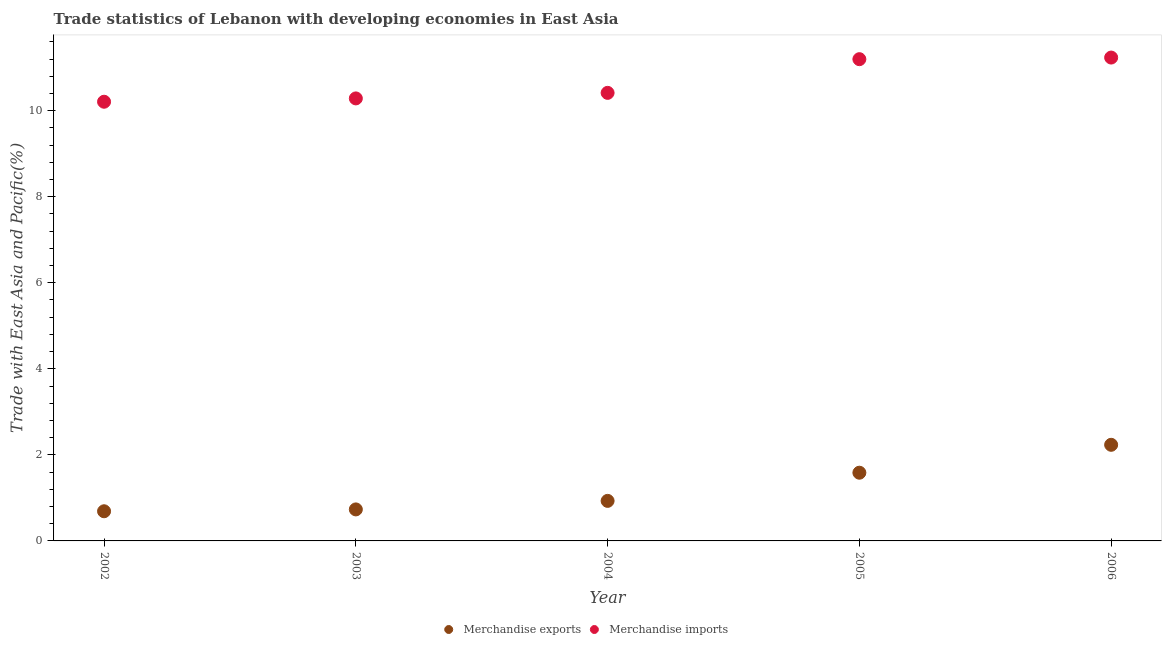How many different coloured dotlines are there?
Offer a terse response. 2. What is the merchandise exports in 2006?
Ensure brevity in your answer.  2.23. Across all years, what is the maximum merchandise imports?
Keep it short and to the point. 11.23. Across all years, what is the minimum merchandise exports?
Ensure brevity in your answer.  0.69. In which year was the merchandise exports minimum?
Ensure brevity in your answer.  2002. What is the total merchandise exports in the graph?
Your answer should be compact. 6.17. What is the difference between the merchandise imports in 2004 and that in 2006?
Make the answer very short. -0.82. What is the difference between the merchandise imports in 2006 and the merchandise exports in 2005?
Provide a short and direct response. 9.65. What is the average merchandise imports per year?
Your answer should be very brief. 10.67. In the year 2003, what is the difference between the merchandise exports and merchandise imports?
Offer a very short reply. -9.55. In how many years, is the merchandise imports greater than 0.4 %?
Your answer should be very brief. 5. What is the ratio of the merchandise exports in 2003 to that in 2006?
Provide a short and direct response. 0.33. What is the difference between the highest and the second highest merchandise exports?
Ensure brevity in your answer.  0.65. What is the difference between the highest and the lowest merchandise exports?
Your response must be concise. 1.54. In how many years, is the merchandise imports greater than the average merchandise imports taken over all years?
Provide a succinct answer. 2. Does the merchandise imports monotonically increase over the years?
Your answer should be very brief. Yes. Is the merchandise exports strictly less than the merchandise imports over the years?
Your answer should be compact. Yes. How many dotlines are there?
Offer a very short reply. 2. What is the difference between two consecutive major ticks on the Y-axis?
Provide a short and direct response. 2. Does the graph contain any zero values?
Make the answer very short. No. Does the graph contain grids?
Offer a very short reply. No. Where does the legend appear in the graph?
Make the answer very short. Bottom center. How many legend labels are there?
Offer a very short reply. 2. What is the title of the graph?
Ensure brevity in your answer.  Trade statistics of Lebanon with developing economies in East Asia. Does "Manufacturing industries and construction" appear as one of the legend labels in the graph?
Provide a short and direct response. No. What is the label or title of the X-axis?
Ensure brevity in your answer.  Year. What is the label or title of the Y-axis?
Keep it short and to the point. Trade with East Asia and Pacific(%). What is the Trade with East Asia and Pacific(%) of Merchandise exports in 2002?
Your answer should be very brief. 0.69. What is the Trade with East Asia and Pacific(%) of Merchandise imports in 2002?
Give a very brief answer. 10.21. What is the Trade with East Asia and Pacific(%) of Merchandise exports in 2003?
Your response must be concise. 0.73. What is the Trade with East Asia and Pacific(%) of Merchandise imports in 2003?
Your answer should be very brief. 10.29. What is the Trade with East Asia and Pacific(%) in Merchandise exports in 2004?
Your answer should be very brief. 0.93. What is the Trade with East Asia and Pacific(%) in Merchandise imports in 2004?
Make the answer very short. 10.41. What is the Trade with East Asia and Pacific(%) in Merchandise exports in 2005?
Your response must be concise. 1.59. What is the Trade with East Asia and Pacific(%) of Merchandise imports in 2005?
Offer a terse response. 11.2. What is the Trade with East Asia and Pacific(%) of Merchandise exports in 2006?
Make the answer very short. 2.23. What is the Trade with East Asia and Pacific(%) in Merchandise imports in 2006?
Offer a very short reply. 11.23. Across all years, what is the maximum Trade with East Asia and Pacific(%) of Merchandise exports?
Ensure brevity in your answer.  2.23. Across all years, what is the maximum Trade with East Asia and Pacific(%) of Merchandise imports?
Your response must be concise. 11.23. Across all years, what is the minimum Trade with East Asia and Pacific(%) in Merchandise exports?
Your response must be concise. 0.69. Across all years, what is the minimum Trade with East Asia and Pacific(%) of Merchandise imports?
Ensure brevity in your answer.  10.21. What is the total Trade with East Asia and Pacific(%) of Merchandise exports in the graph?
Keep it short and to the point. 6.17. What is the total Trade with East Asia and Pacific(%) in Merchandise imports in the graph?
Make the answer very short. 53.34. What is the difference between the Trade with East Asia and Pacific(%) of Merchandise exports in 2002 and that in 2003?
Your response must be concise. -0.04. What is the difference between the Trade with East Asia and Pacific(%) in Merchandise imports in 2002 and that in 2003?
Provide a succinct answer. -0.08. What is the difference between the Trade with East Asia and Pacific(%) of Merchandise exports in 2002 and that in 2004?
Provide a succinct answer. -0.24. What is the difference between the Trade with East Asia and Pacific(%) of Merchandise imports in 2002 and that in 2004?
Offer a terse response. -0.21. What is the difference between the Trade with East Asia and Pacific(%) in Merchandise exports in 2002 and that in 2005?
Give a very brief answer. -0.9. What is the difference between the Trade with East Asia and Pacific(%) in Merchandise imports in 2002 and that in 2005?
Your answer should be compact. -0.99. What is the difference between the Trade with East Asia and Pacific(%) in Merchandise exports in 2002 and that in 2006?
Offer a very short reply. -1.54. What is the difference between the Trade with East Asia and Pacific(%) in Merchandise imports in 2002 and that in 2006?
Ensure brevity in your answer.  -1.03. What is the difference between the Trade with East Asia and Pacific(%) in Merchandise exports in 2003 and that in 2004?
Provide a succinct answer. -0.2. What is the difference between the Trade with East Asia and Pacific(%) in Merchandise imports in 2003 and that in 2004?
Your answer should be compact. -0.13. What is the difference between the Trade with East Asia and Pacific(%) of Merchandise exports in 2003 and that in 2005?
Provide a short and direct response. -0.85. What is the difference between the Trade with East Asia and Pacific(%) in Merchandise imports in 2003 and that in 2005?
Make the answer very short. -0.91. What is the difference between the Trade with East Asia and Pacific(%) of Merchandise exports in 2003 and that in 2006?
Offer a very short reply. -1.5. What is the difference between the Trade with East Asia and Pacific(%) in Merchandise imports in 2003 and that in 2006?
Your response must be concise. -0.95. What is the difference between the Trade with East Asia and Pacific(%) in Merchandise exports in 2004 and that in 2005?
Provide a succinct answer. -0.65. What is the difference between the Trade with East Asia and Pacific(%) of Merchandise imports in 2004 and that in 2005?
Offer a terse response. -0.78. What is the difference between the Trade with East Asia and Pacific(%) of Merchandise exports in 2004 and that in 2006?
Your answer should be very brief. -1.3. What is the difference between the Trade with East Asia and Pacific(%) of Merchandise imports in 2004 and that in 2006?
Provide a short and direct response. -0.82. What is the difference between the Trade with East Asia and Pacific(%) of Merchandise exports in 2005 and that in 2006?
Provide a short and direct response. -0.65. What is the difference between the Trade with East Asia and Pacific(%) in Merchandise imports in 2005 and that in 2006?
Provide a short and direct response. -0.04. What is the difference between the Trade with East Asia and Pacific(%) of Merchandise exports in 2002 and the Trade with East Asia and Pacific(%) of Merchandise imports in 2003?
Give a very brief answer. -9.6. What is the difference between the Trade with East Asia and Pacific(%) in Merchandise exports in 2002 and the Trade with East Asia and Pacific(%) in Merchandise imports in 2004?
Offer a terse response. -9.72. What is the difference between the Trade with East Asia and Pacific(%) in Merchandise exports in 2002 and the Trade with East Asia and Pacific(%) in Merchandise imports in 2005?
Make the answer very short. -10.51. What is the difference between the Trade with East Asia and Pacific(%) in Merchandise exports in 2002 and the Trade with East Asia and Pacific(%) in Merchandise imports in 2006?
Provide a succinct answer. -10.55. What is the difference between the Trade with East Asia and Pacific(%) of Merchandise exports in 2003 and the Trade with East Asia and Pacific(%) of Merchandise imports in 2004?
Keep it short and to the point. -9.68. What is the difference between the Trade with East Asia and Pacific(%) of Merchandise exports in 2003 and the Trade with East Asia and Pacific(%) of Merchandise imports in 2005?
Make the answer very short. -10.46. What is the difference between the Trade with East Asia and Pacific(%) of Merchandise exports in 2003 and the Trade with East Asia and Pacific(%) of Merchandise imports in 2006?
Provide a short and direct response. -10.5. What is the difference between the Trade with East Asia and Pacific(%) in Merchandise exports in 2004 and the Trade with East Asia and Pacific(%) in Merchandise imports in 2005?
Offer a very short reply. -10.27. What is the difference between the Trade with East Asia and Pacific(%) in Merchandise exports in 2004 and the Trade with East Asia and Pacific(%) in Merchandise imports in 2006?
Make the answer very short. -10.3. What is the difference between the Trade with East Asia and Pacific(%) in Merchandise exports in 2005 and the Trade with East Asia and Pacific(%) in Merchandise imports in 2006?
Keep it short and to the point. -9.65. What is the average Trade with East Asia and Pacific(%) of Merchandise exports per year?
Your answer should be compact. 1.23. What is the average Trade with East Asia and Pacific(%) of Merchandise imports per year?
Your answer should be very brief. 10.67. In the year 2002, what is the difference between the Trade with East Asia and Pacific(%) in Merchandise exports and Trade with East Asia and Pacific(%) in Merchandise imports?
Your answer should be compact. -9.52. In the year 2003, what is the difference between the Trade with East Asia and Pacific(%) of Merchandise exports and Trade with East Asia and Pacific(%) of Merchandise imports?
Give a very brief answer. -9.55. In the year 2004, what is the difference between the Trade with East Asia and Pacific(%) in Merchandise exports and Trade with East Asia and Pacific(%) in Merchandise imports?
Ensure brevity in your answer.  -9.48. In the year 2005, what is the difference between the Trade with East Asia and Pacific(%) in Merchandise exports and Trade with East Asia and Pacific(%) in Merchandise imports?
Your answer should be very brief. -9.61. In the year 2006, what is the difference between the Trade with East Asia and Pacific(%) of Merchandise exports and Trade with East Asia and Pacific(%) of Merchandise imports?
Keep it short and to the point. -9. What is the ratio of the Trade with East Asia and Pacific(%) in Merchandise exports in 2002 to that in 2003?
Ensure brevity in your answer.  0.94. What is the ratio of the Trade with East Asia and Pacific(%) of Merchandise imports in 2002 to that in 2003?
Your answer should be compact. 0.99. What is the ratio of the Trade with East Asia and Pacific(%) of Merchandise exports in 2002 to that in 2004?
Your answer should be very brief. 0.74. What is the ratio of the Trade with East Asia and Pacific(%) in Merchandise imports in 2002 to that in 2004?
Make the answer very short. 0.98. What is the ratio of the Trade with East Asia and Pacific(%) of Merchandise exports in 2002 to that in 2005?
Provide a succinct answer. 0.43. What is the ratio of the Trade with East Asia and Pacific(%) of Merchandise imports in 2002 to that in 2005?
Your response must be concise. 0.91. What is the ratio of the Trade with East Asia and Pacific(%) in Merchandise exports in 2002 to that in 2006?
Ensure brevity in your answer.  0.31. What is the ratio of the Trade with East Asia and Pacific(%) of Merchandise imports in 2002 to that in 2006?
Keep it short and to the point. 0.91. What is the ratio of the Trade with East Asia and Pacific(%) in Merchandise exports in 2003 to that in 2004?
Your answer should be very brief. 0.79. What is the ratio of the Trade with East Asia and Pacific(%) of Merchandise imports in 2003 to that in 2004?
Keep it short and to the point. 0.99. What is the ratio of the Trade with East Asia and Pacific(%) in Merchandise exports in 2003 to that in 2005?
Make the answer very short. 0.46. What is the ratio of the Trade with East Asia and Pacific(%) in Merchandise imports in 2003 to that in 2005?
Give a very brief answer. 0.92. What is the ratio of the Trade with East Asia and Pacific(%) in Merchandise exports in 2003 to that in 2006?
Offer a very short reply. 0.33. What is the ratio of the Trade with East Asia and Pacific(%) of Merchandise imports in 2003 to that in 2006?
Your answer should be very brief. 0.92. What is the ratio of the Trade with East Asia and Pacific(%) in Merchandise exports in 2004 to that in 2005?
Your answer should be compact. 0.59. What is the ratio of the Trade with East Asia and Pacific(%) of Merchandise imports in 2004 to that in 2005?
Your answer should be very brief. 0.93. What is the ratio of the Trade with East Asia and Pacific(%) of Merchandise exports in 2004 to that in 2006?
Your response must be concise. 0.42. What is the ratio of the Trade with East Asia and Pacific(%) in Merchandise imports in 2004 to that in 2006?
Make the answer very short. 0.93. What is the ratio of the Trade with East Asia and Pacific(%) of Merchandise exports in 2005 to that in 2006?
Offer a very short reply. 0.71. What is the ratio of the Trade with East Asia and Pacific(%) in Merchandise imports in 2005 to that in 2006?
Your answer should be very brief. 1. What is the difference between the highest and the second highest Trade with East Asia and Pacific(%) of Merchandise exports?
Ensure brevity in your answer.  0.65. What is the difference between the highest and the second highest Trade with East Asia and Pacific(%) of Merchandise imports?
Provide a short and direct response. 0.04. What is the difference between the highest and the lowest Trade with East Asia and Pacific(%) in Merchandise exports?
Provide a short and direct response. 1.54. What is the difference between the highest and the lowest Trade with East Asia and Pacific(%) in Merchandise imports?
Keep it short and to the point. 1.03. 